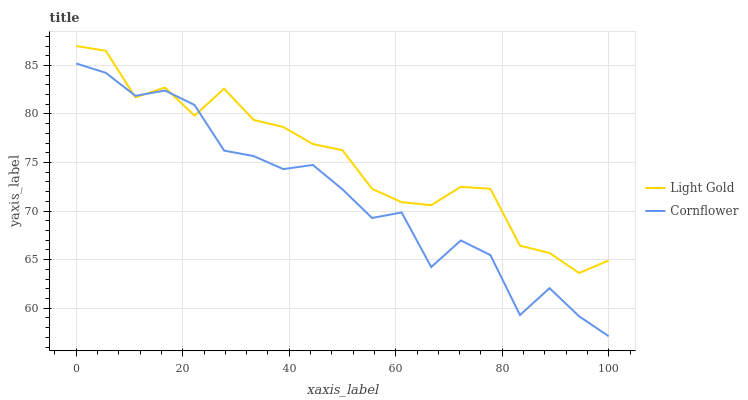Does Cornflower have the minimum area under the curve?
Answer yes or no. Yes. Does Light Gold have the maximum area under the curve?
Answer yes or no. Yes. Does Light Gold have the minimum area under the curve?
Answer yes or no. No. Is Light Gold the smoothest?
Answer yes or no. Yes. Is Cornflower the roughest?
Answer yes or no. Yes. Is Light Gold the roughest?
Answer yes or no. No. Does Cornflower have the lowest value?
Answer yes or no. Yes. Does Light Gold have the lowest value?
Answer yes or no. No. Does Light Gold have the highest value?
Answer yes or no. Yes. Does Cornflower intersect Light Gold?
Answer yes or no. Yes. Is Cornflower less than Light Gold?
Answer yes or no. No. Is Cornflower greater than Light Gold?
Answer yes or no. No. 